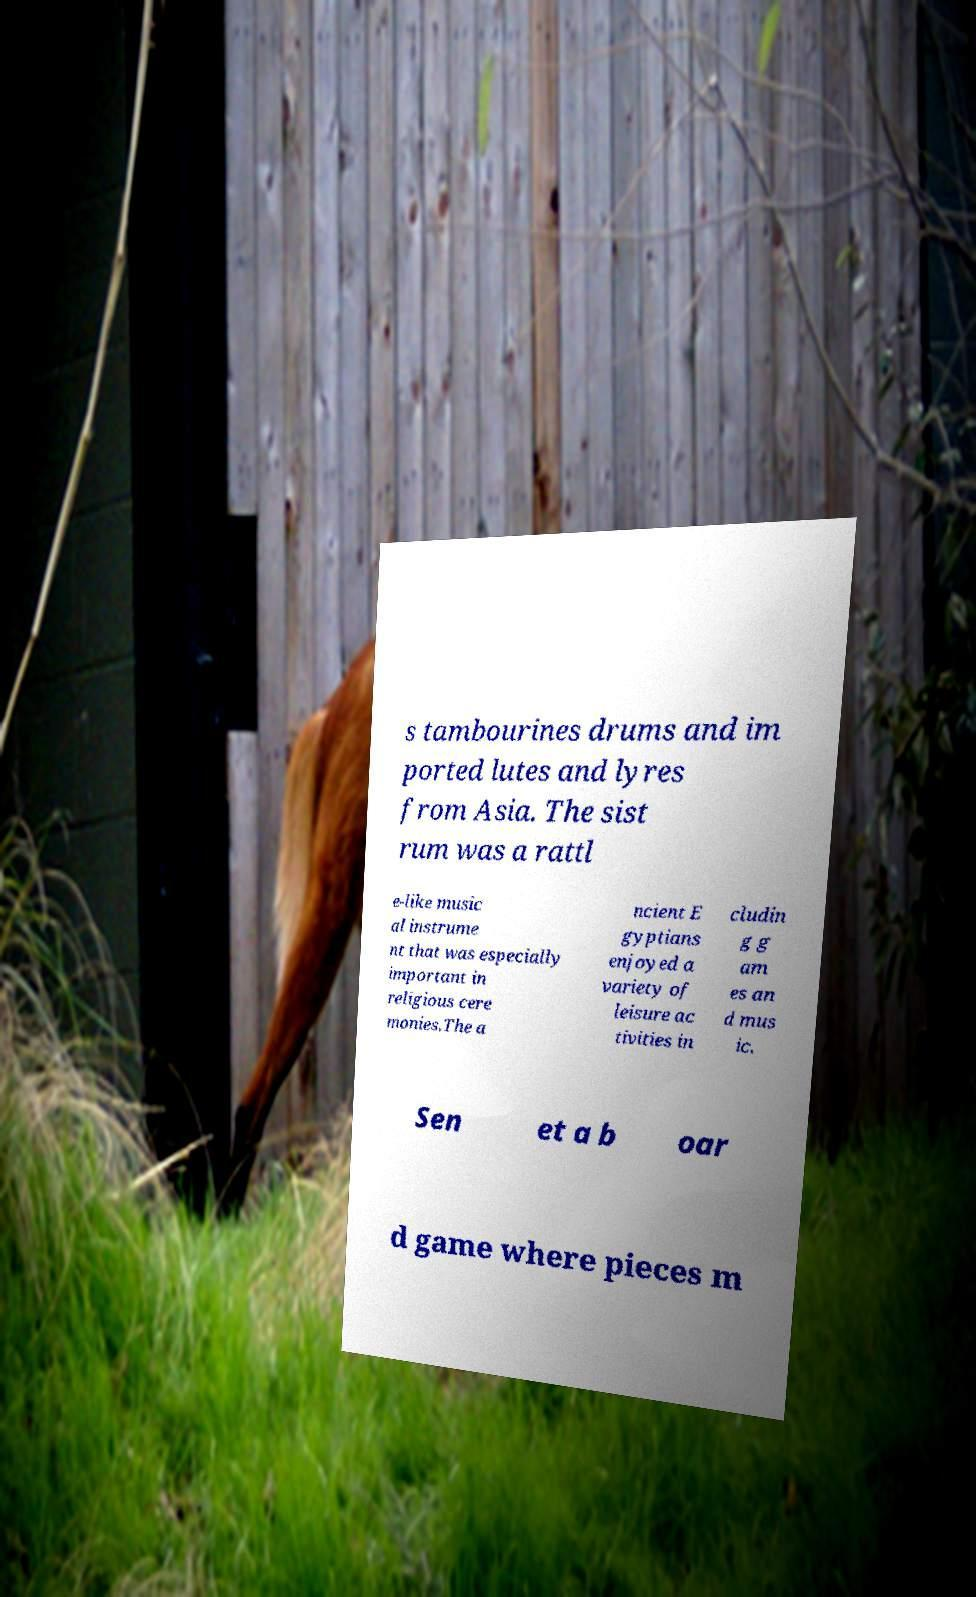Can you accurately transcribe the text from the provided image for me? s tambourines drums and im ported lutes and lyres from Asia. The sist rum was a rattl e-like music al instrume nt that was especially important in religious cere monies.The a ncient E gyptians enjoyed a variety of leisure ac tivities in cludin g g am es an d mus ic. Sen et a b oar d game where pieces m 